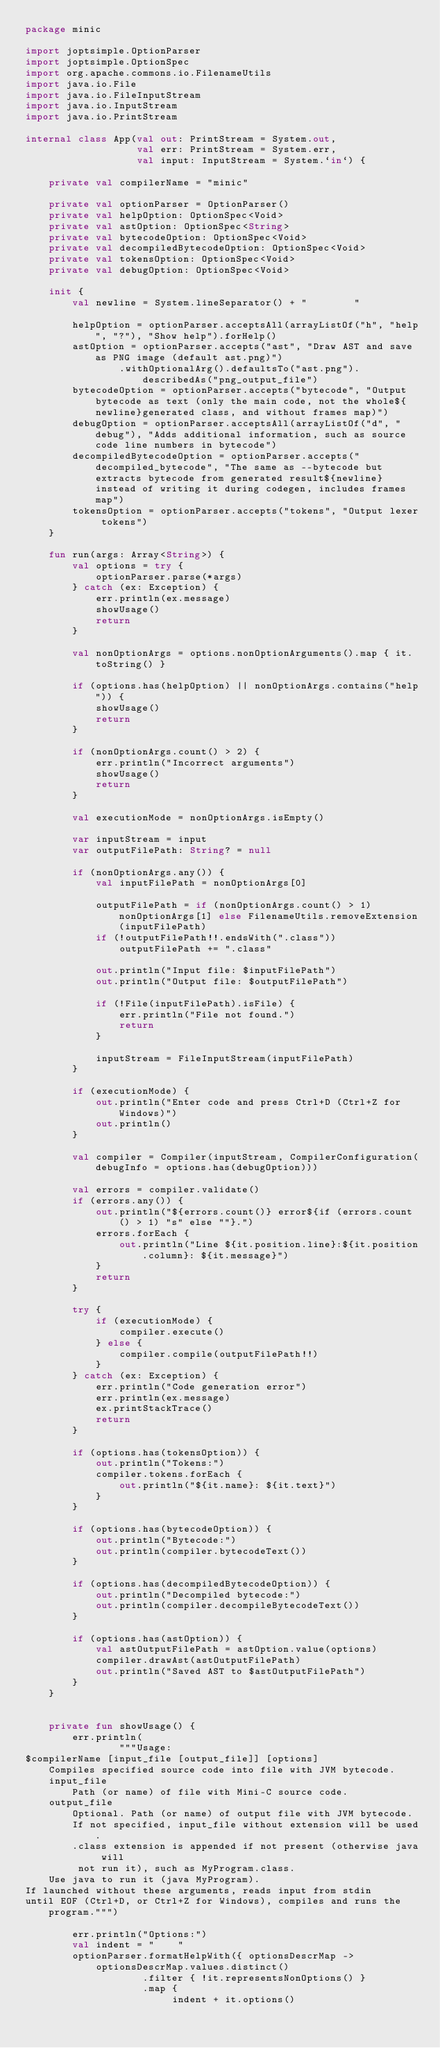<code> <loc_0><loc_0><loc_500><loc_500><_Kotlin_>package minic

import joptsimple.OptionParser
import joptsimple.OptionSpec
import org.apache.commons.io.FilenameUtils
import java.io.File
import java.io.FileInputStream
import java.io.InputStream
import java.io.PrintStream

internal class App(val out: PrintStream = System.out,
                   val err: PrintStream = System.err,
                   val input: InputStream = System.`in`) {

    private val compilerName = "minic"

    private val optionParser = OptionParser()
    private val helpOption: OptionSpec<Void>
    private val astOption: OptionSpec<String>
    private val bytecodeOption: OptionSpec<Void>
    private val decompiledBytecodeOption: OptionSpec<Void>
    private val tokensOption: OptionSpec<Void>
    private val debugOption: OptionSpec<Void>

    init {
        val newline = System.lineSeparator() + "        "

        helpOption = optionParser.acceptsAll(arrayListOf("h", "help", "?"), "Show help").forHelp()
        astOption = optionParser.accepts("ast", "Draw AST and save as PNG image (default ast.png)")
                .withOptionalArg().defaultsTo("ast.png").describedAs("png_output_file")
        bytecodeOption = optionParser.accepts("bytecode", "Output bytecode as text (only the main code, not the whole${newline}generated class, and without frames map)")
        debugOption = optionParser.acceptsAll(arrayListOf("d", "debug"), "Adds additional information, such as source code line numbers in bytecode")
        decompiledBytecodeOption = optionParser.accepts("decompiled_bytecode", "The same as --bytecode but extracts bytecode from generated result${newline}instead of writing it during codegen, includes frames map")
        tokensOption = optionParser.accepts("tokens", "Output lexer tokens")
    }

    fun run(args: Array<String>) {
        val options = try {
            optionParser.parse(*args)
        } catch (ex: Exception) {
            err.println(ex.message)
            showUsage()
            return
        }

        val nonOptionArgs = options.nonOptionArguments().map { it.toString() }

        if (options.has(helpOption) || nonOptionArgs.contains("help")) {
            showUsage()
            return
        }

        if (nonOptionArgs.count() > 2) {
            err.println("Incorrect arguments")
            showUsage()
            return
        }

        val executionMode = nonOptionArgs.isEmpty()

        var inputStream = input
        var outputFilePath: String? = null

        if (nonOptionArgs.any()) {
            val inputFilePath = nonOptionArgs[0]

            outputFilePath = if (nonOptionArgs.count() > 1) nonOptionArgs[1] else FilenameUtils.removeExtension(inputFilePath)
            if (!outputFilePath!!.endsWith(".class"))
                outputFilePath += ".class"

            out.println("Input file: $inputFilePath")
            out.println("Output file: $outputFilePath")

            if (!File(inputFilePath).isFile) {
                err.println("File not found.")
                return
            }

            inputStream = FileInputStream(inputFilePath)
        }

        if (executionMode) {
            out.println("Enter code and press Ctrl+D (Ctrl+Z for Windows)")
            out.println()
        }

        val compiler = Compiler(inputStream, CompilerConfiguration(debugInfo = options.has(debugOption)))

        val errors = compiler.validate()
        if (errors.any()) {
            out.println("${errors.count()} error${if (errors.count() > 1) "s" else ""}.")
            errors.forEach {
                out.println("Line ${it.position.line}:${it.position.column}: ${it.message}")
            }
            return
        }

        try {
            if (executionMode) {
                compiler.execute()
            } else {
                compiler.compile(outputFilePath!!)
            }
        } catch (ex: Exception) {
            err.println("Code generation error")
            err.println(ex.message)
            ex.printStackTrace()
            return
        }

        if (options.has(tokensOption)) {
            out.println("Tokens:")
            compiler.tokens.forEach {
                out.println("${it.name}: ${it.text}")
            }
        }

        if (options.has(bytecodeOption)) {
            out.println("Bytecode:")
            out.println(compiler.bytecodeText())
        }

        if (options.has(decompiledBytecodeOption)) {
            out.println("Decompiled bytecode:")
            out.println(compiler.decompileBytecodeText())
        }

        if (options.has(astOption)) {
            val astOutputFilePath = astOption.value(options)
            compiler.drawAst(astOutputFilePath)
            out.println("Saved AST to $astOutputFilePath")
        }
    }


    private fun showUsage() {
        err.println(
                """Usage:
$compilerName [input_file [output_file]] [options]
    Compiles specified source code into file with JVM bytecode.
    input_file
        Path (or name) of file with Mini-C source code.
    output_file
        Optional. Path (or name) of output file with JVM bytecode.
        If not specified, input_file without extension will be used.
        .class extension is appended if not present (otherwise java will
         not run it), such as MyProgram.class.
    Use java to run it (java MyProgram).
If launched without these arguments, reads input from stdin
until EOF (Ctrl+D, or Ctrl+Z for Windows), compiles and runs the program.""")

        err.println("Options:")
        val indent = "    "
        optionParser.formatHelpWith({ optionsDescrMap ->
            optionsDescrMap.values.distinct()
                    .filter { !it.representsNonOptions() }
                    .map {
                         indent + it.options()</code> 